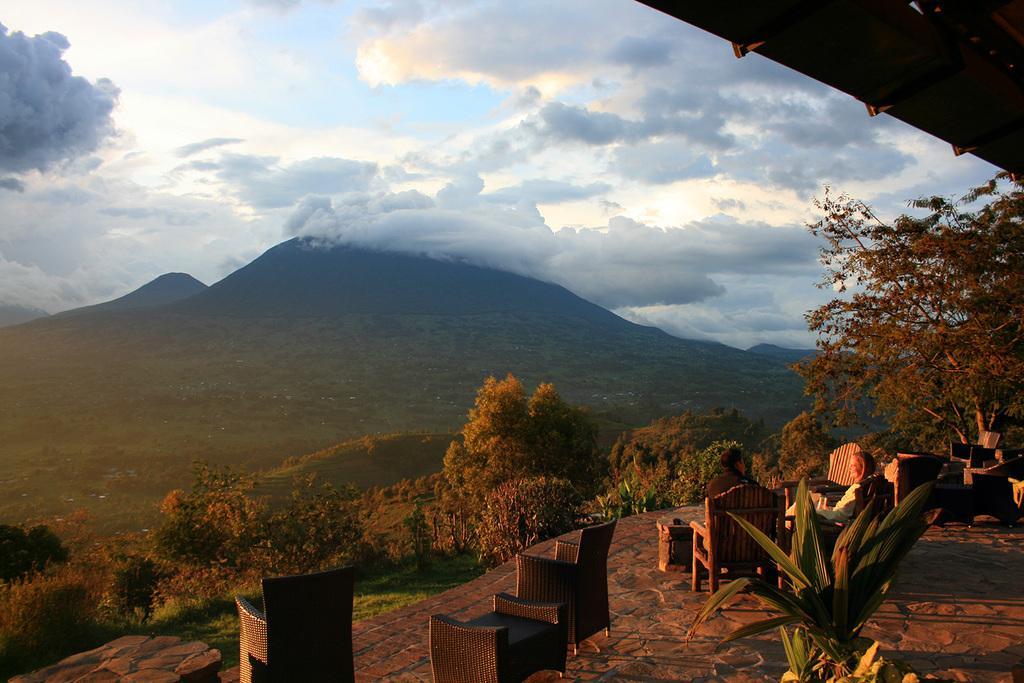Can you describe this image briefly? In this image we can see some mountains, trees, grass and the sky which looks cloudy. On the right side we can see a plant, a man and a woman sitting on the chairs. We can also see some empty chairs on the floor. 